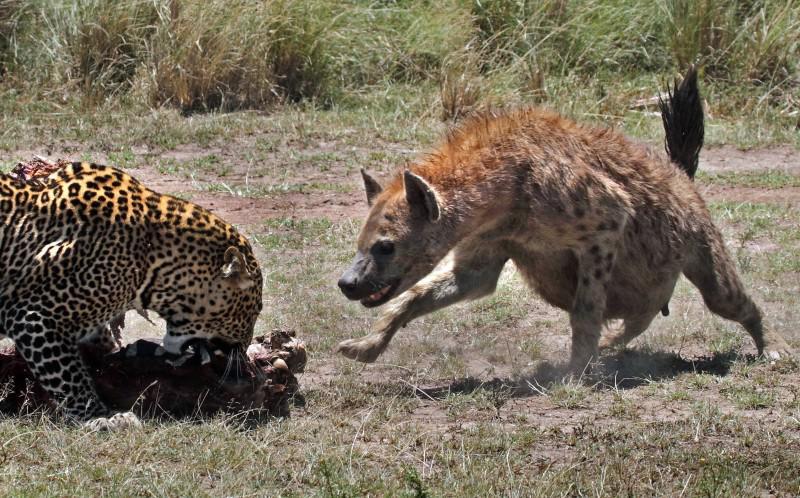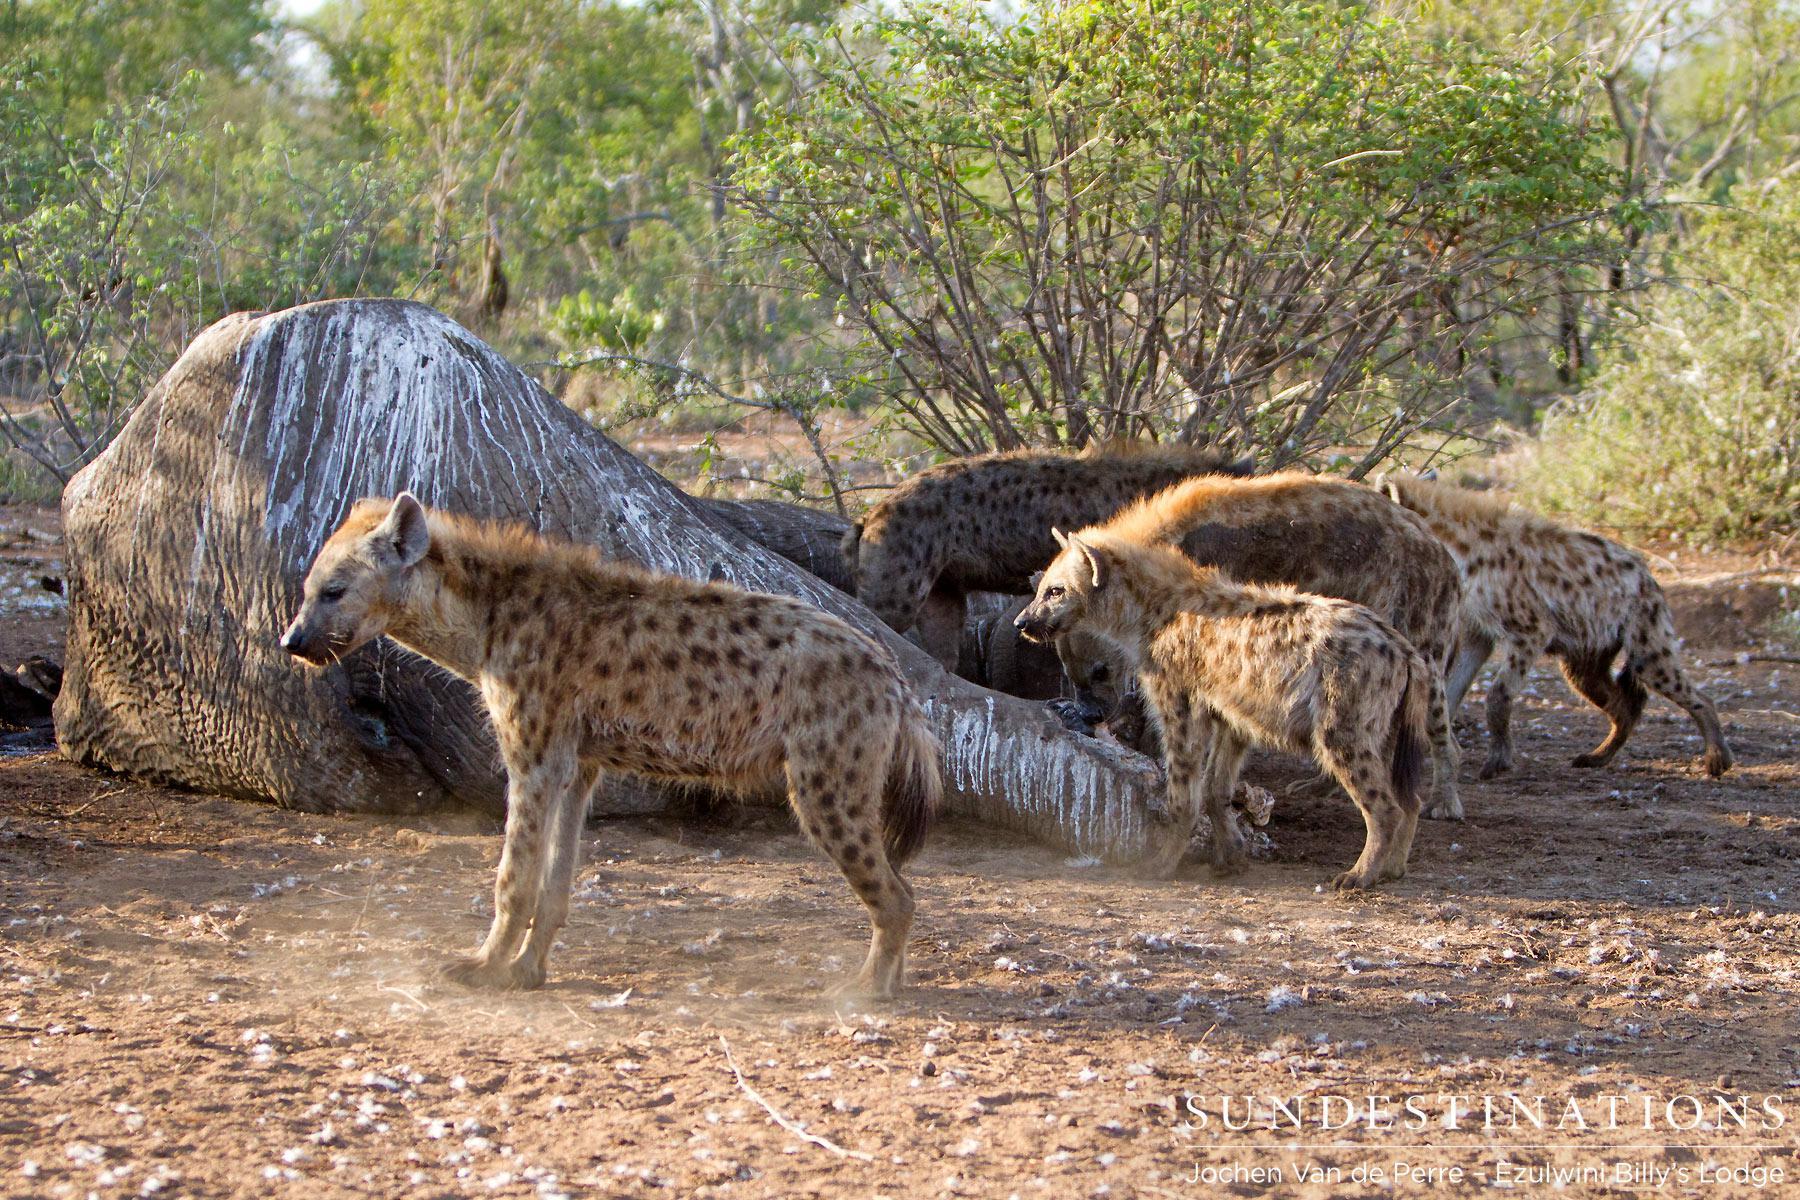The first image is the image on the left, the second image is the image on the right. Considering the images on both sides, is "The right image includes at least one leftward-facing hyena standing in front of a large rock, but does not include a carcass or any other type of animal in the foreground." valid? Answer yes or no. Yes. 